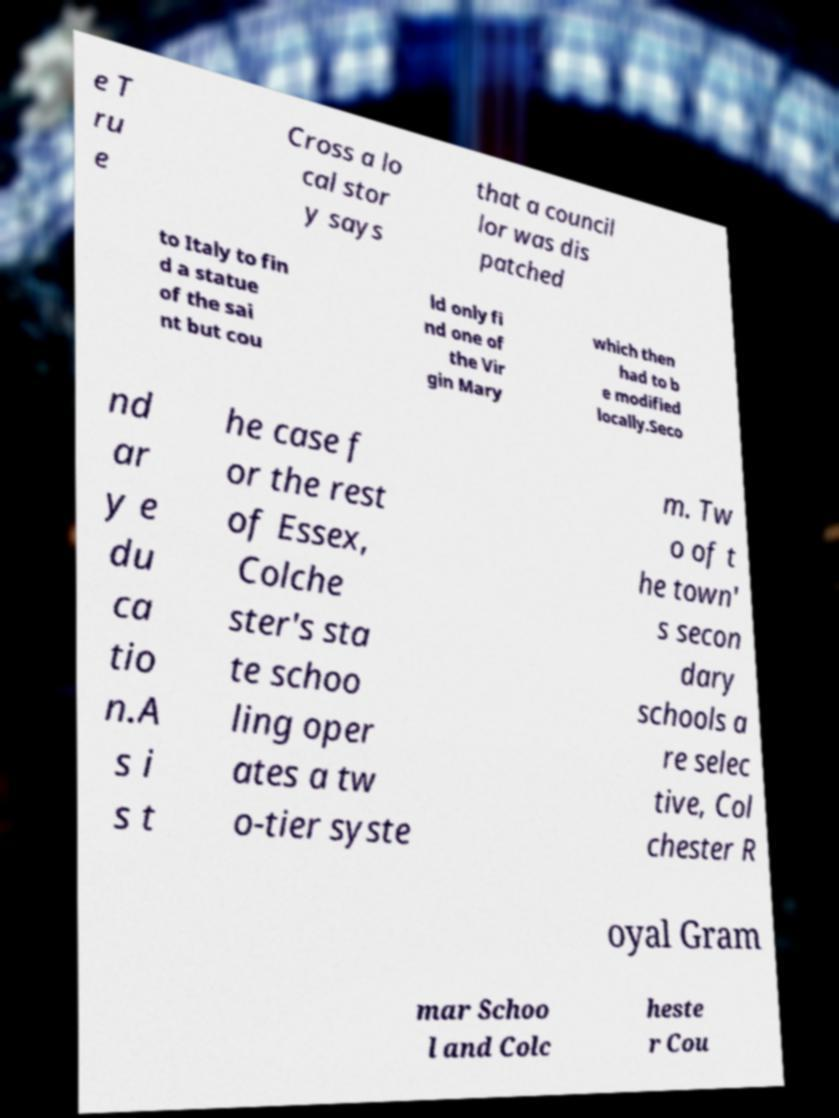Can you accurately transcribe the text from the provided image for me? e T ru e Cross a lo cal stor y says that a council lor was dis patched to Italy to fin d a statue of the sai nt but cou ld only fi nd one of the Vir gin Mary which then had to b e modified locally.Seco nd ar y e du ca tio n.A s i s t he case f or the rest of Essex, Colche ster's sta te schoo ling oper ates a tw o-tier syste m. Tw o of t he town' s secon dary schools a re selec tive, Col chester R oyal Gram mar Schoo l and Colc heste r Cou 